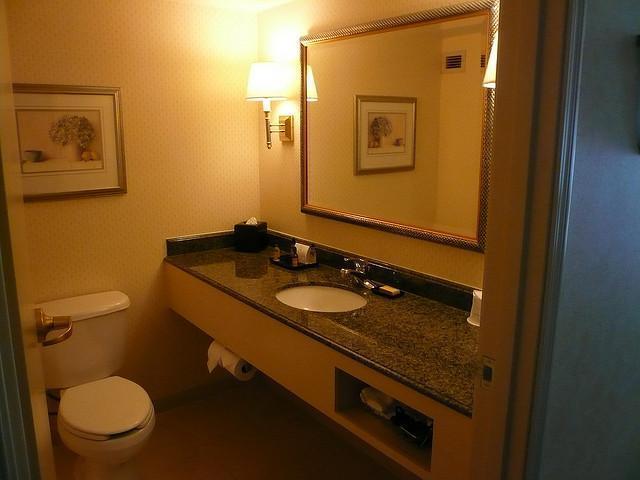How many sinks are there?
Give a very brief answer. 1. How many light bulbs are there?
Give a very brief answer. 2. How many lights are there?
Give a very brief answer. 2. 